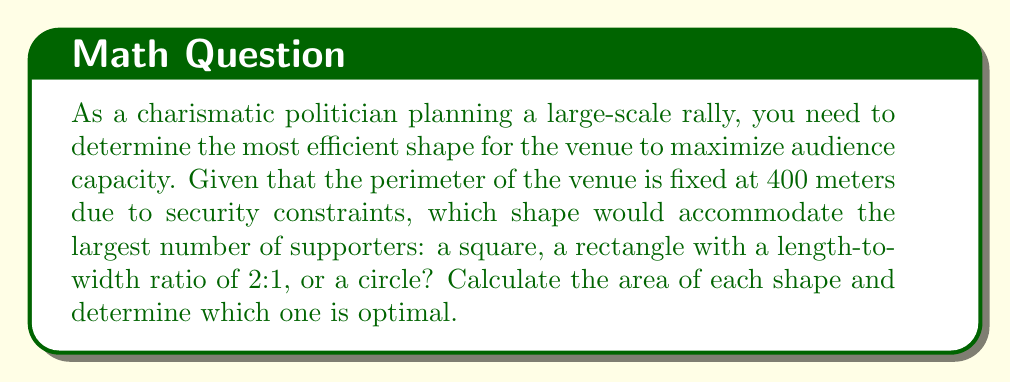Teach me how to tackle this problem. Let's calculate the area for each shape:

1. Square:
   - Side length: $s = 400 \div 4 = 100$ m
   - Area: $A_s = s^2 = 100^2 = 10,000$ m²

2. Rectangle (2:1 ratio):
   - Let width be $w$ and length be $2w$
   - Perimeter equation: $2w + 2(2w) = 400$
   - Solve for $w$: $6w = 400$, so $w = 66.67$ m
   - Length: $2w = 133.33$ m
   - Area: $A_r = w \cdot 2w = 66.67 \cdot 133.33 = 8,888.89$ m²

3. Circle:
   - Circumference: $C = 2\pi r = 400$
   - Radius: $r = \frac{400}{2\pi} = 63.66$ m
   - Area: $A_c = \pi r^2 = \pi \cdot 63.66^2 = 12,732.39$ m²

Comparing the areas:
   $A_c > A_s > A_r$

The circle has the largest area, making it the most efficient shape for maximizing audience capacity.

[asy]
import geometry;

size(200);

// Circle
draw(circle((0,0), 1), blue);
label("Circle", (0,1.2), blue);

// Square
draw((-0.8,-0.8)--(0.8,-0.8)--(0.8,0.8)--(-0.8,0.8)--cycle, red);
label("Square", (-0.8,1), red);

// Rectangle
draw((-1.2,-0.4)--(1.2,-0.4)--(1.2,0.4)--(-1.2,0.4)--cycle, green);
label("Rectangle", (1.2,0.6), green);

label("Areas:", (-1.5,-1.2));
label("Circle > Square > Rectangle", (0,-1.5));
[/asy]
Answer: Circle with area 12,732.39 m² 